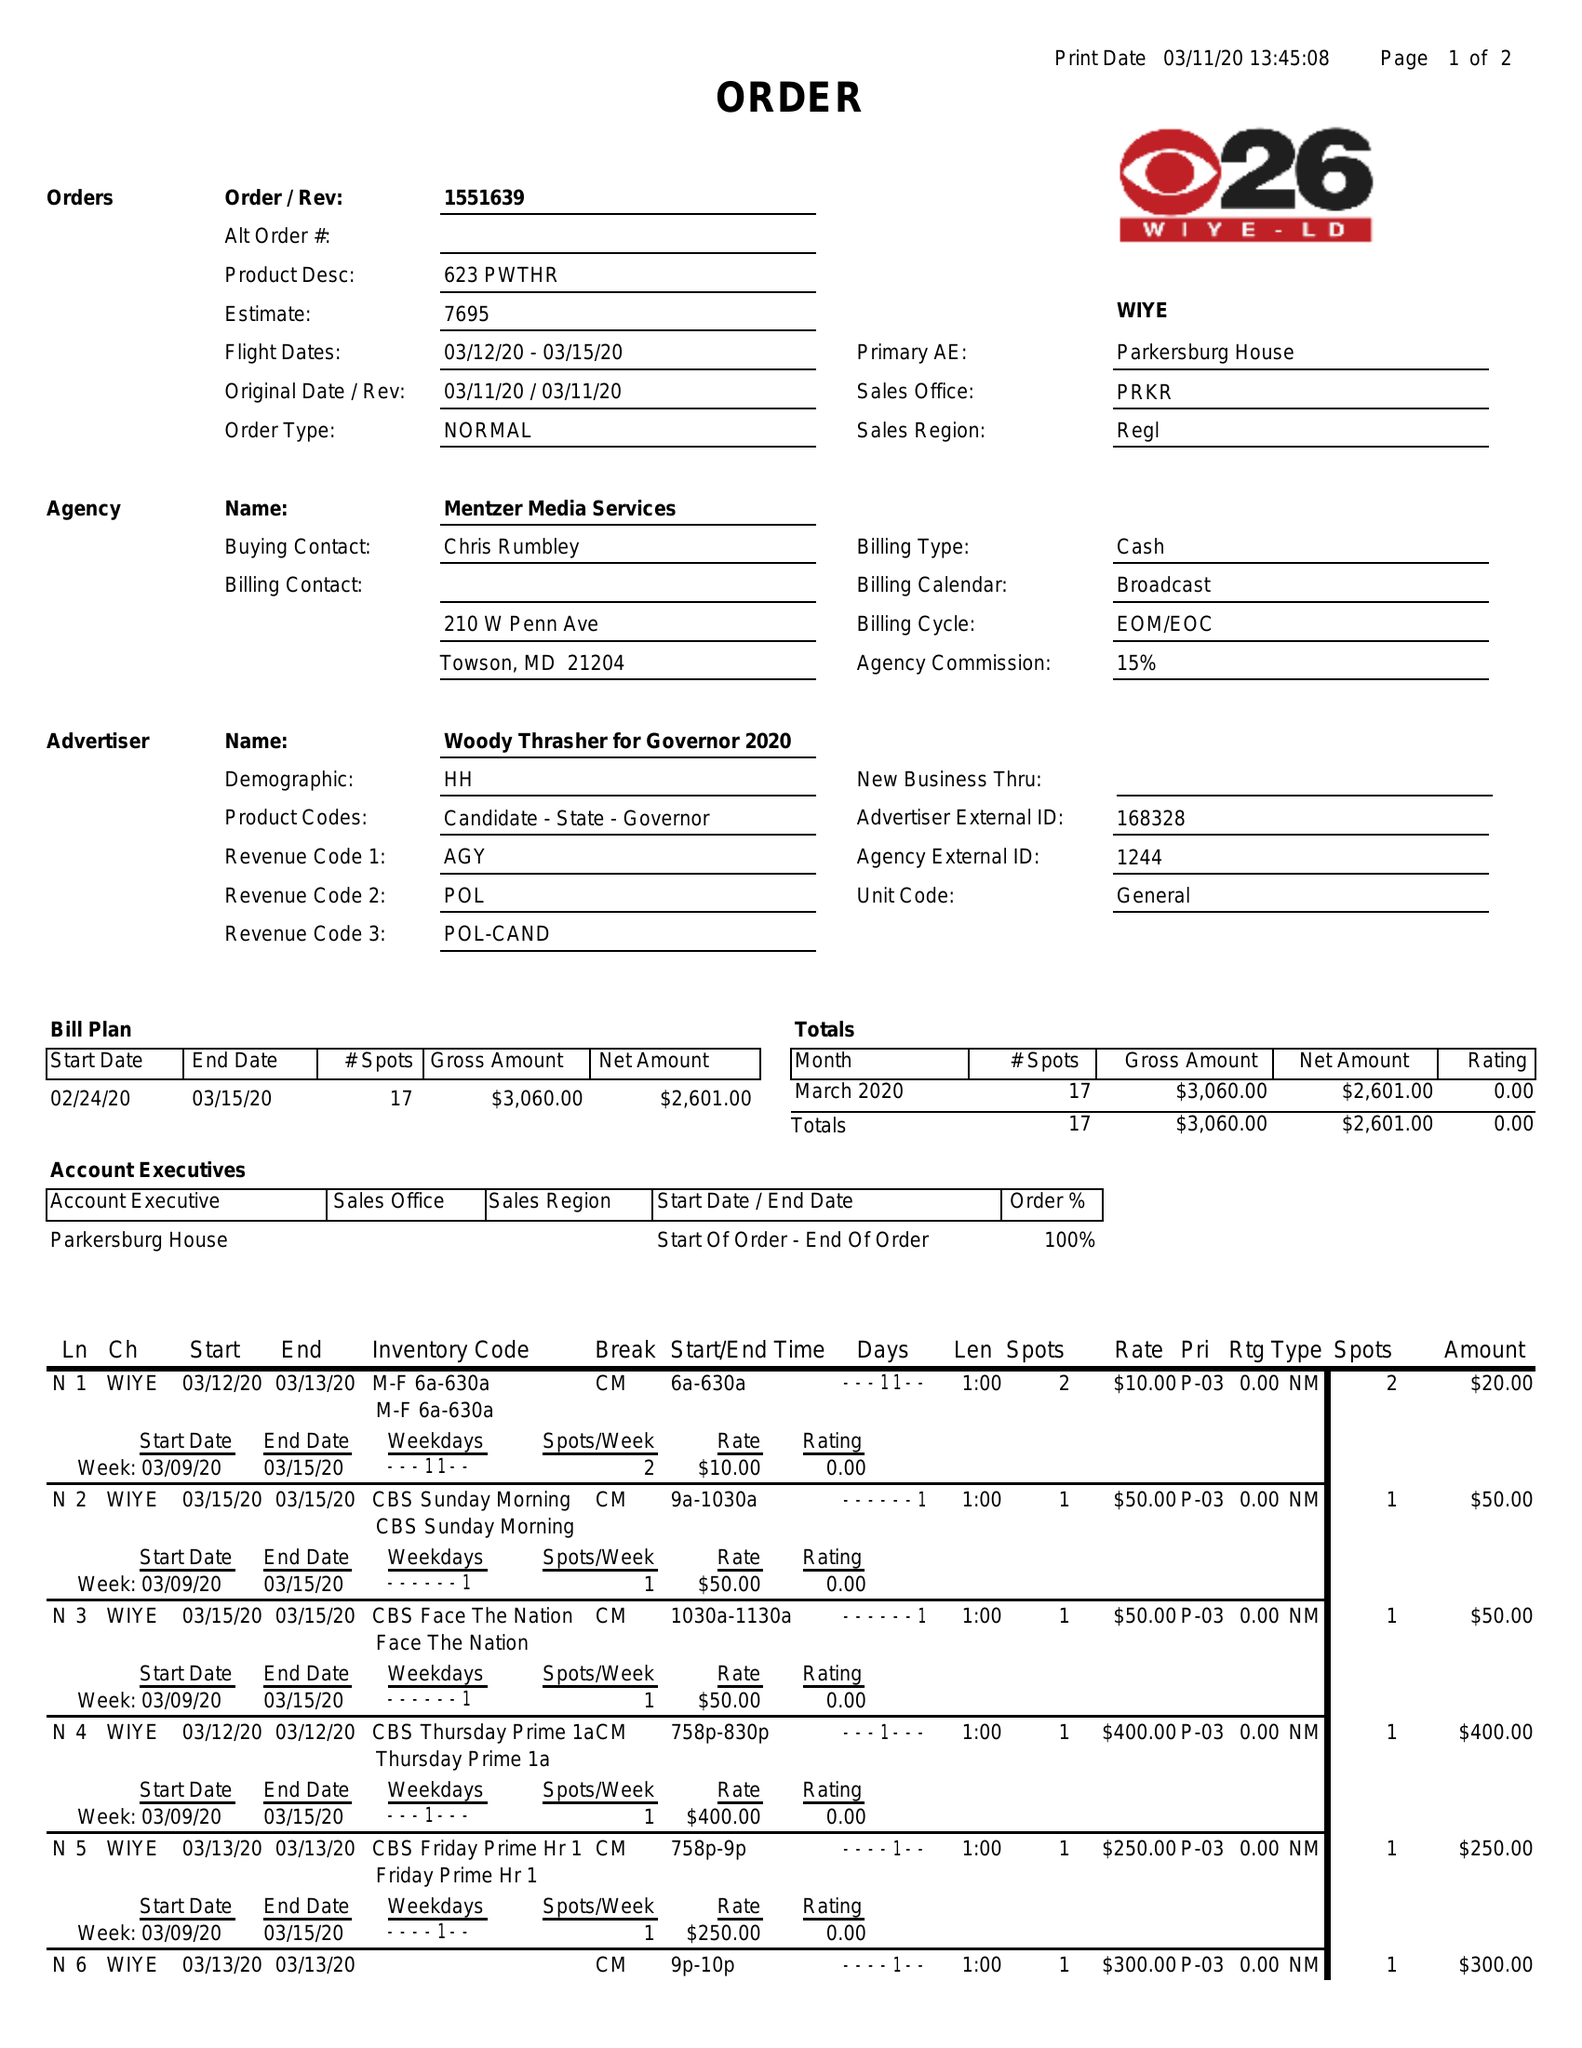What is the value for the advertiser?
Answer the question using a single word or phrase. WOODY THRASHER FOR GOVERNOR 2020 